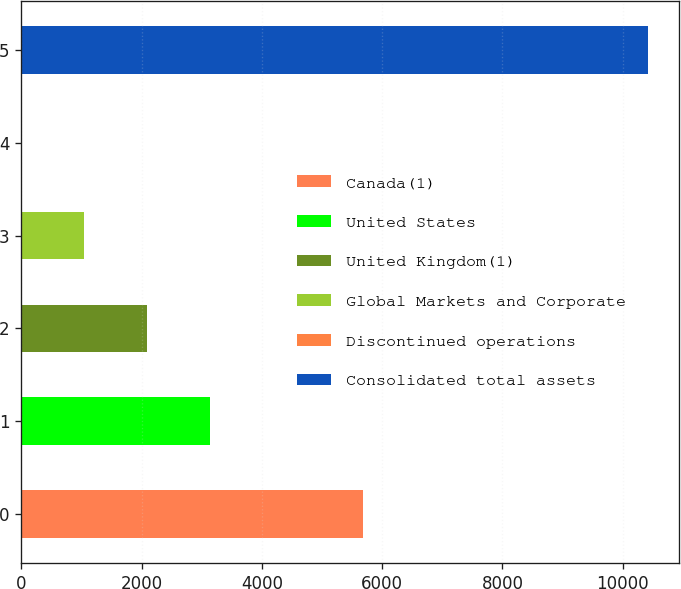<chart> <loc_0><loc_0><loc_500><loc_500><bar_chart><fcel>Canada(1)<fcel>United States<fcel>United Kingdom(1)<fcel>Global Markets and Corporate<fcel>Discontinued operations<fcel>Consolidated total assets<nl><fcel>5688.1<fcel>3130.93<fcel>2090.12<fcel>1049.31<fcel>8.5<fcel>10416.6<nl></chart> 